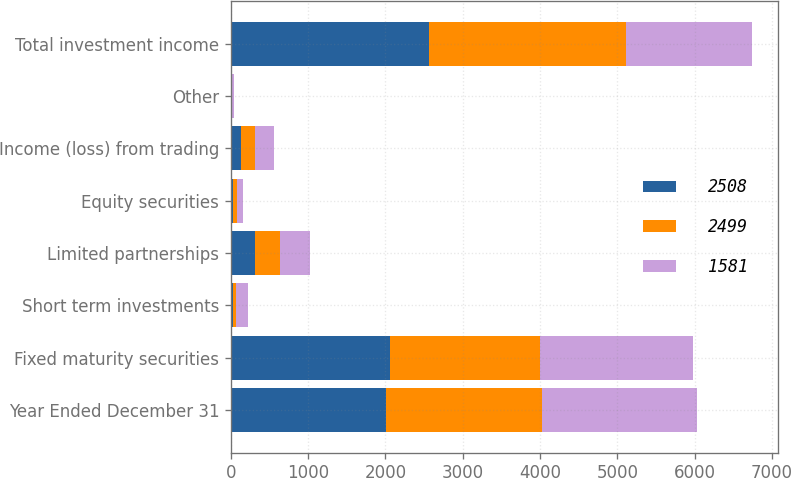Convert chart to OTSL. <chart><loc_0><loc_0><loc_500><loc_500><stacked_bar_chart><ecel><fcel>Year Ended December 31<fcel>Fixed maturity securities<fcel>Short term investments<fcel>Limited partnerships<fcel>Equity securities<fcel>Income (loss) from trading<fcel>Other<fcel>Total investment income<nl><fcel>2508<fcel>2010<fcel>2052<fcel>22<fcel>315<fcel>32<fcel>131<fcel>10<fcel>2562<nl><fcel>2499<fcel>2009<fcel>1941<fcel>42<fcel>324<fcel>49<fcel>187<fcel>6<fcel>2549<nl><fcel>1581<fcel>2008<fcel>1984<fcel>162<fcel>379<fcel>80<fcel>234<fcel>19<fcel>1632<nl></chart> 